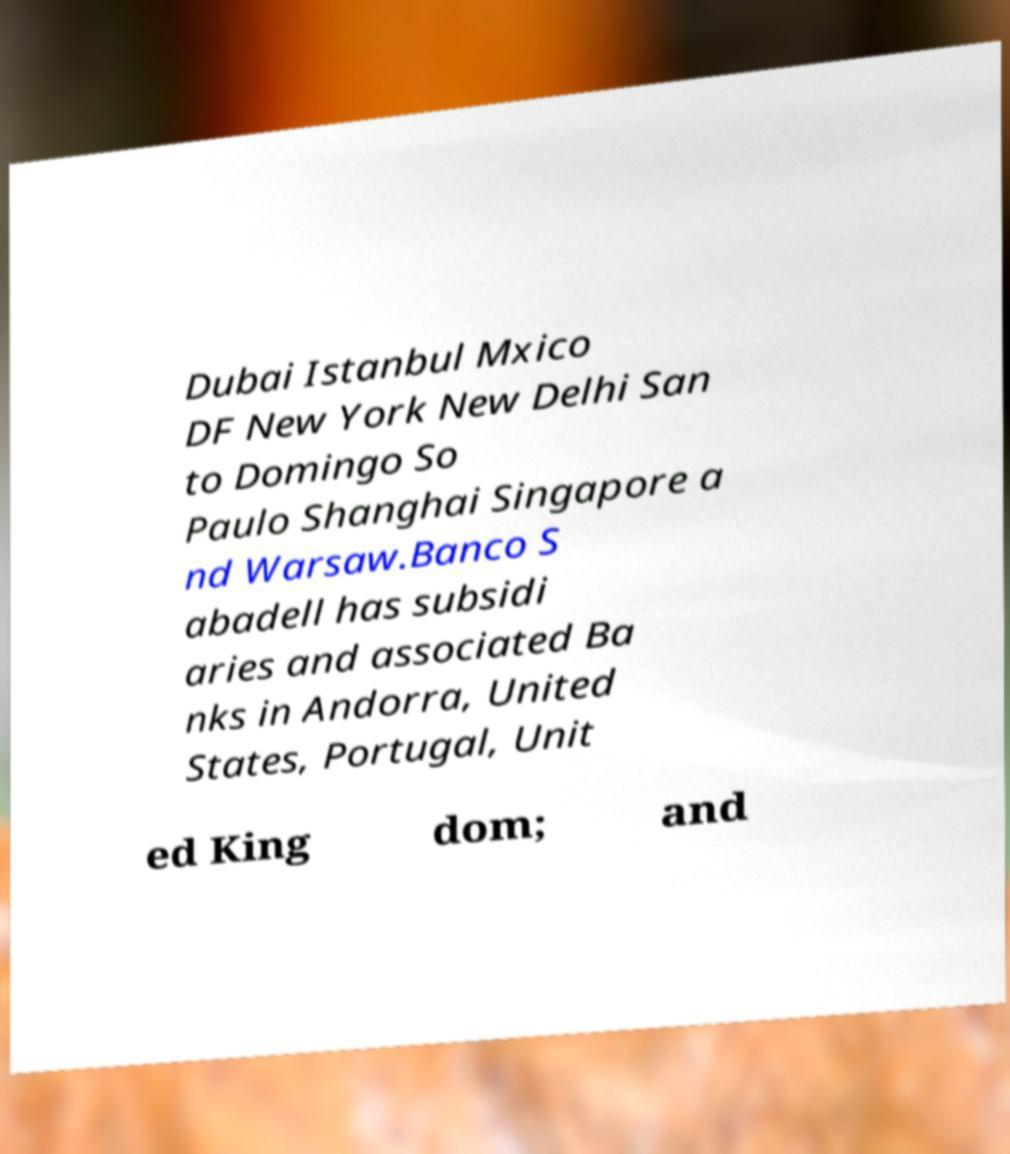Can you read and provide the text displayed in the image?This photo seems to have some interesting text. Can you extract and type it out for me? Dubai Istanbul Mxico DF New York New Delhi San to Domingo So Paulo Shanghai Singapore a nd Warsaw.Banco S abadell has subsidi aries and associated Ba nks in Andorra, United States, Portugal, Unit ed King dom; and 